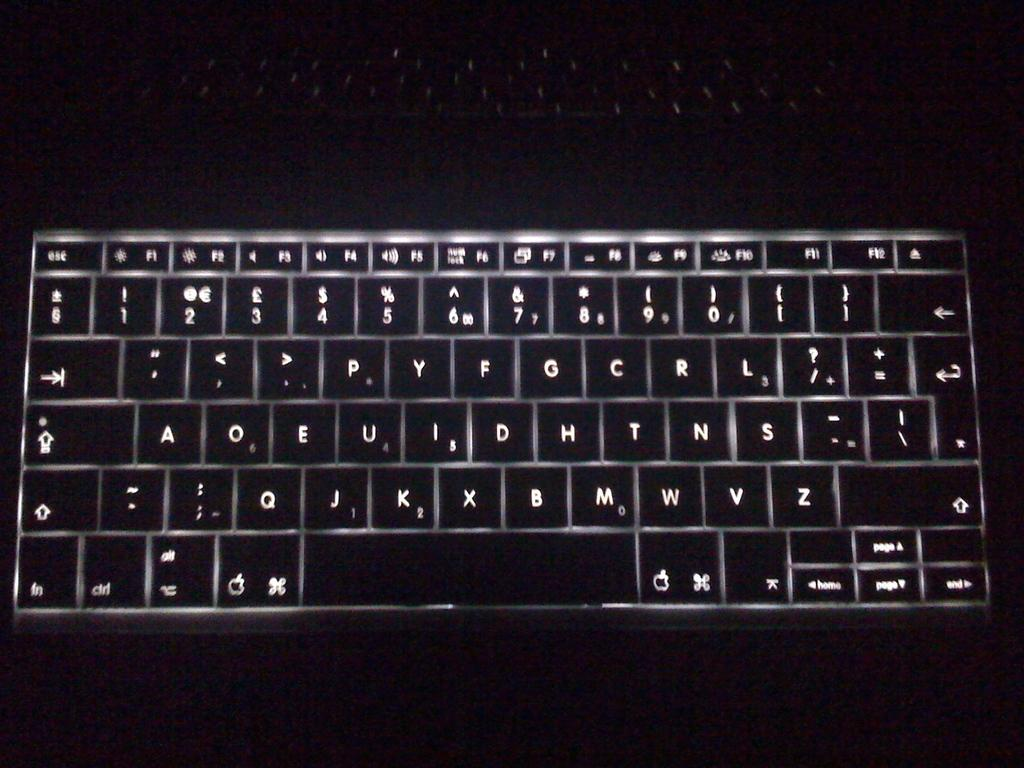<image>
Render a clear and concise summary of the photo. a keyboard that is lit up and the letters 'a' 'o' and 'e' are on it next to one another 